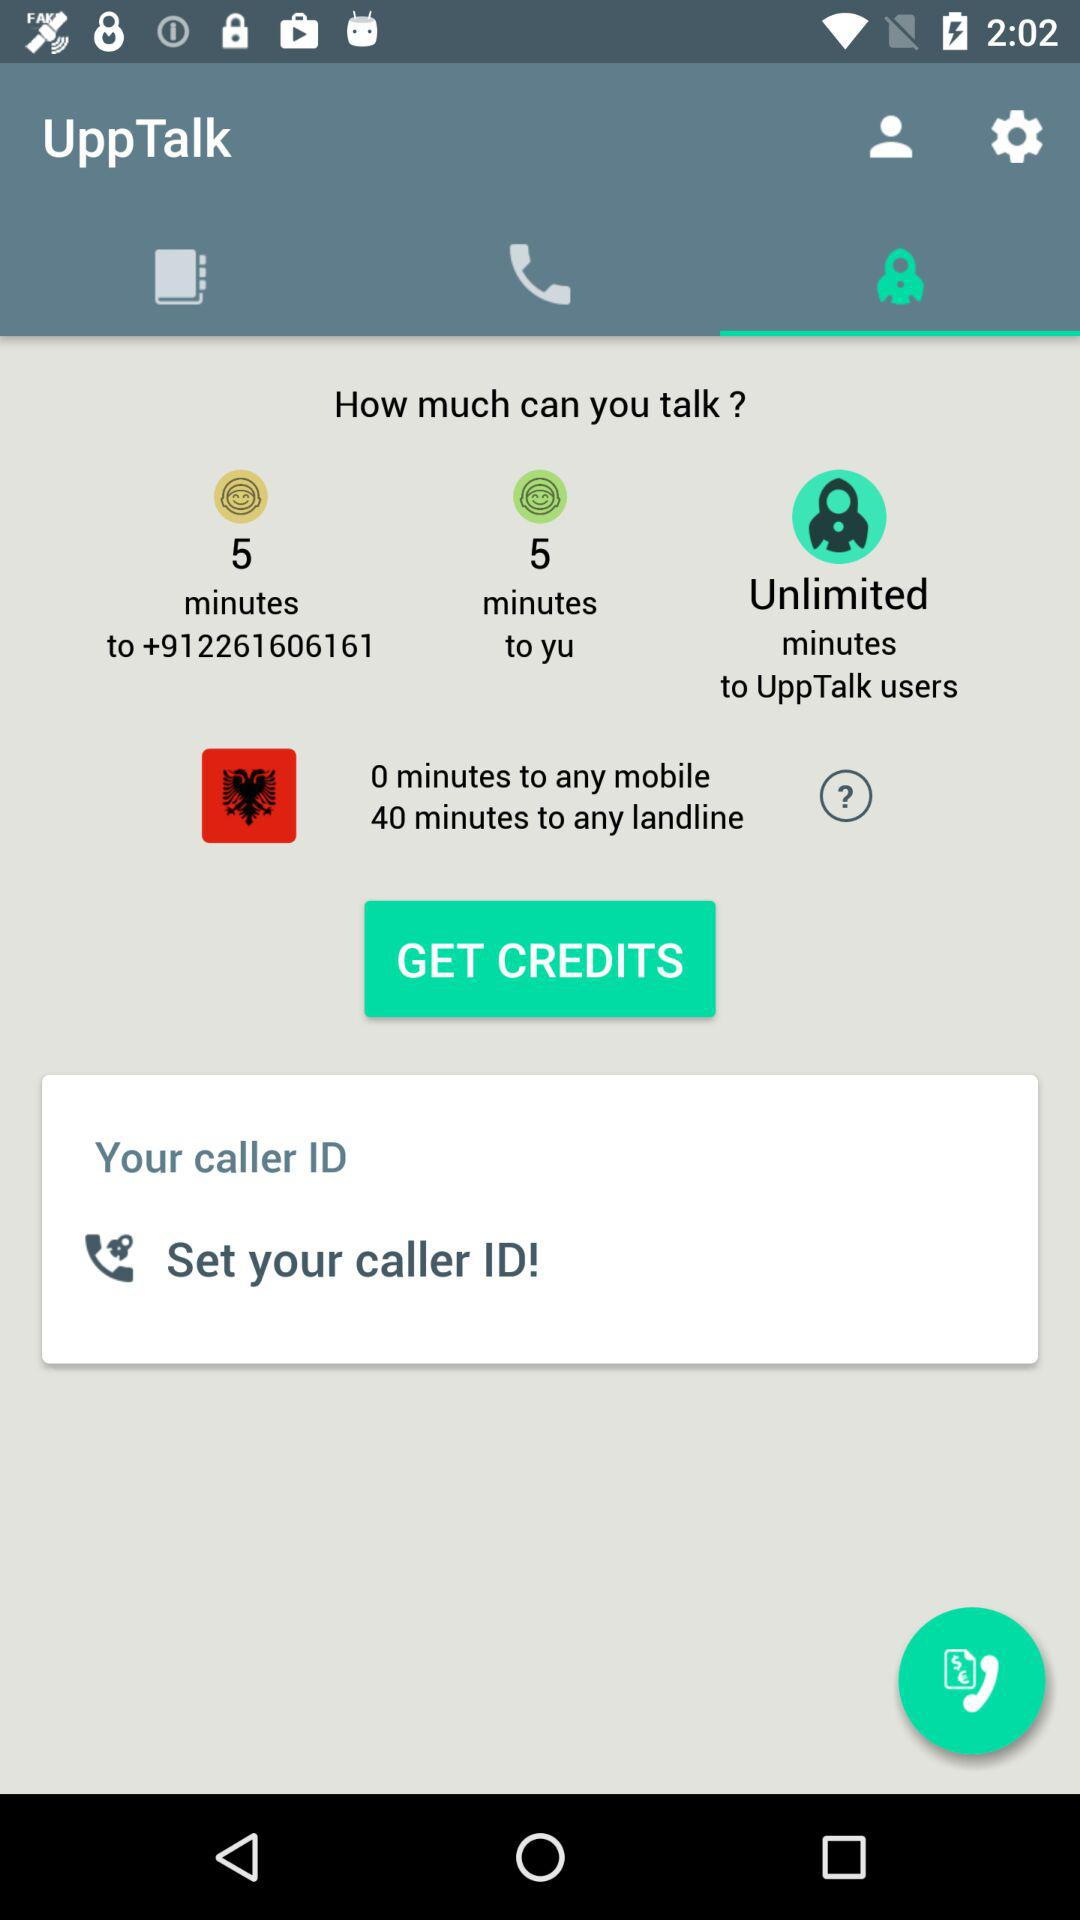What is the given contact number? The given contact number is +912261606161. 